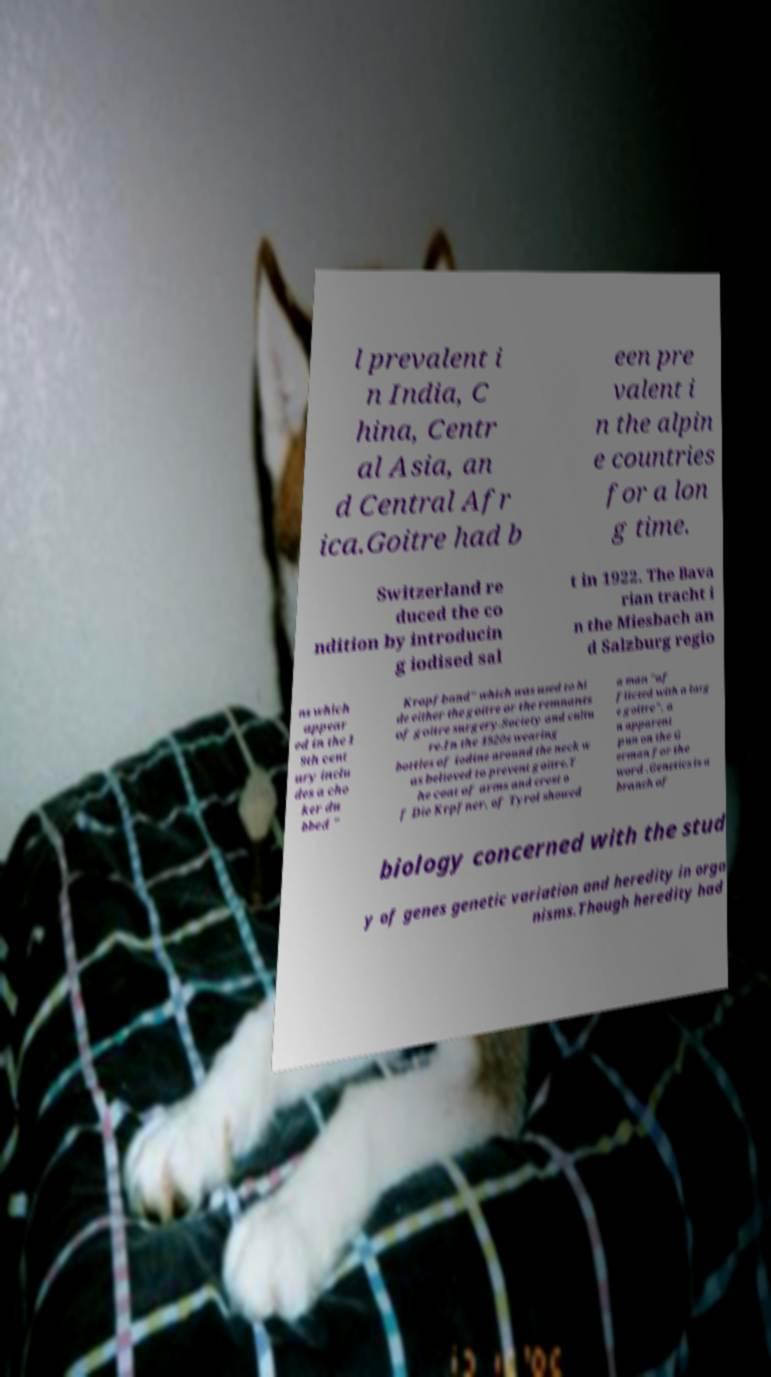Please read and relay the text visible in this image. What does it say? l prevalent i n India, C hina, Centr al Asia, an d Central Afr ica.Goitre had b een pre valent i n the alpin e countries for a lon g time. Switzerland re duced the co ndition by introducin g iodised sal t in 1922. The Bava rian tracht i n the Miesbach an d Salzburg regio ns which appear ed in the 1 9th cent ury inclu des a cho ker du bbed " Kropfband" which was used to hi de either the goitre or the remnants of goitre surgery.Society and cultu re.In the 1920s wearing bottles of iodine around the neck w as believed to prevent goitre.T he coat of arms and crest o f Die Krpfner, of Tyrol showed a man "af flicted with a larg e goitre", a n apparent pun on the G erman for the word .Genetics is a branch of biology concerned with the stud y of genes genetic variation and heredity in orga nisms.Though heredity had 